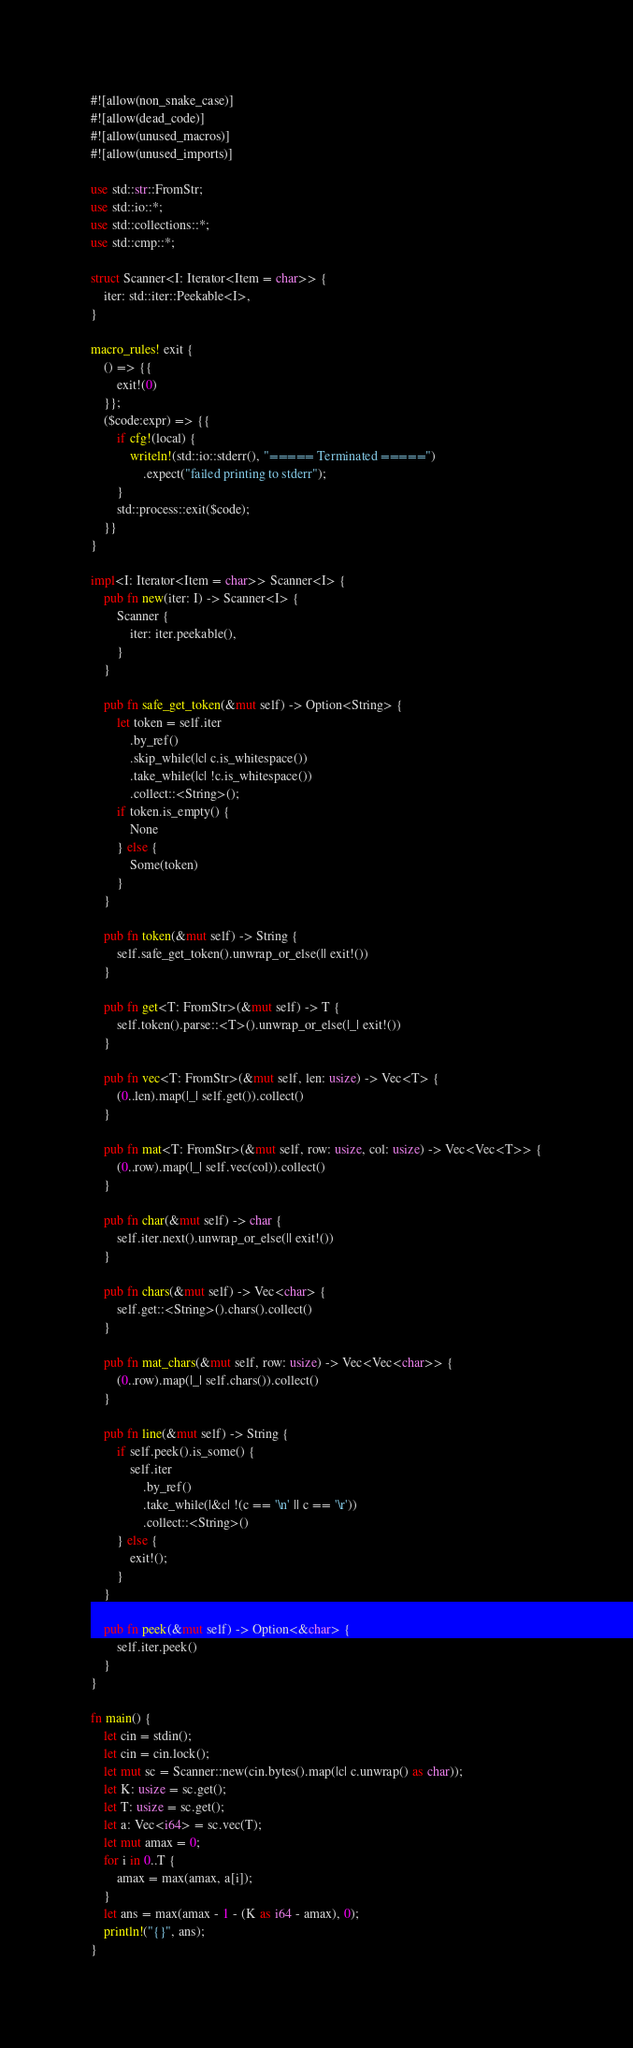<code> <loc_0><loc_0><loc_500><loc_500><_Rust_>#![allow(non_snake_case)]
#![allow(dead_code)]
#![allow(unused_macros)]
#![allow(unused_imports)]

use std::str::FromStr;
use std::io::*;
use std::collections::*;
use std::cmp::*;

struct Scanner<I: Iterator<Item = char>> {
    iter: std::iter::Peekable<I>,
}

macro_rules! exit {
    () => {{
        exit!(0)
    }};
    ($code:expr) => {{
        if cfg!(local) {
            writeln!(std::io::stderr(), "===== Terminated =====")
                .expect("failed printing to stderr");
        }
        std::process::exit($code);
    }}
}

impl<I: Iterator<Item = char>> Scanner<I> {
    pub fn new(iter: I) -> Scanner<I> {
        Scanner {
            iter: iter.peekable(),
        }
    }

    pub fn safe_get_token(&mut self) -> Option<String> {
        let token = self.iter
            .by_ref()
            .skip_while(|c| c.is_whitespace())
            .take_while(|c| !c.is_whitespace())
            .collect::<String>();
        if token.is_empty() {
            None
        } else {
            Some(token)
        }
    }

    pub fn token(&mut self) -> String {
        self.safe_get_token().unwrap_or_else(|| exit!())
    }

    pub fn get<T: FromStr>(&mut self) -> T {
        self.token().parse::<T>().unwrap_or_else(|_| exit!())
    }

    pub fn vec<T: FromStr>(&mut self, len: usize) -> Vec<T> {
        (0..len).map(|_| self.get()).collect()
    }

    pub fn mat<T: FromStr>(&mut self, row: usize, col: usize) -> Vec<Vec<T>> {
        (0..row).map(|_| self.vec(col)).collect()
    }

    pub fn char(&mut self) -> char {
        self.iter.next().unwrap_or_else(|| exit!())
    }

    pub fn chars(&mut self) -> Vec<char> {
        self.get::<String>().chars().collect()
    }

    pub fn mat_chars(&mut self, row: usize) -> Vec<Vec<char>> {
        (0..row).map(|_| self.chars()).collect()
    }

    pub fn line(&mut self) -> String {
        if self.peek().is_some() {
            self.iter
                .by_ref()
                .take_while(|&c| !(c == '\n' || c == '\r'))
                .collect::<String>()
        } else {
            exit!();
        }
    }

    pub fn peek(&mut self) -> Option<&char> {
        self.iter.peek()
    }
}

fn main() {
    let cin = stdin();
    let cin = cin.lock();
    let mut sc = Scanner::new(cin.bytes().map(|c| c.unwrap() as char));
    let K: usize = sc.get();
    let T: usize = sc.get();
    let a: Vec<i64> = sc.vec(T);
    let mut amax = 0;
    for i in 0..T {
        amax = max(amax, a[i]);
    }
    let ans = max(amax - 1 - (K as i64 - amax), 0);
    println!("{}", ans);
}
</code> 